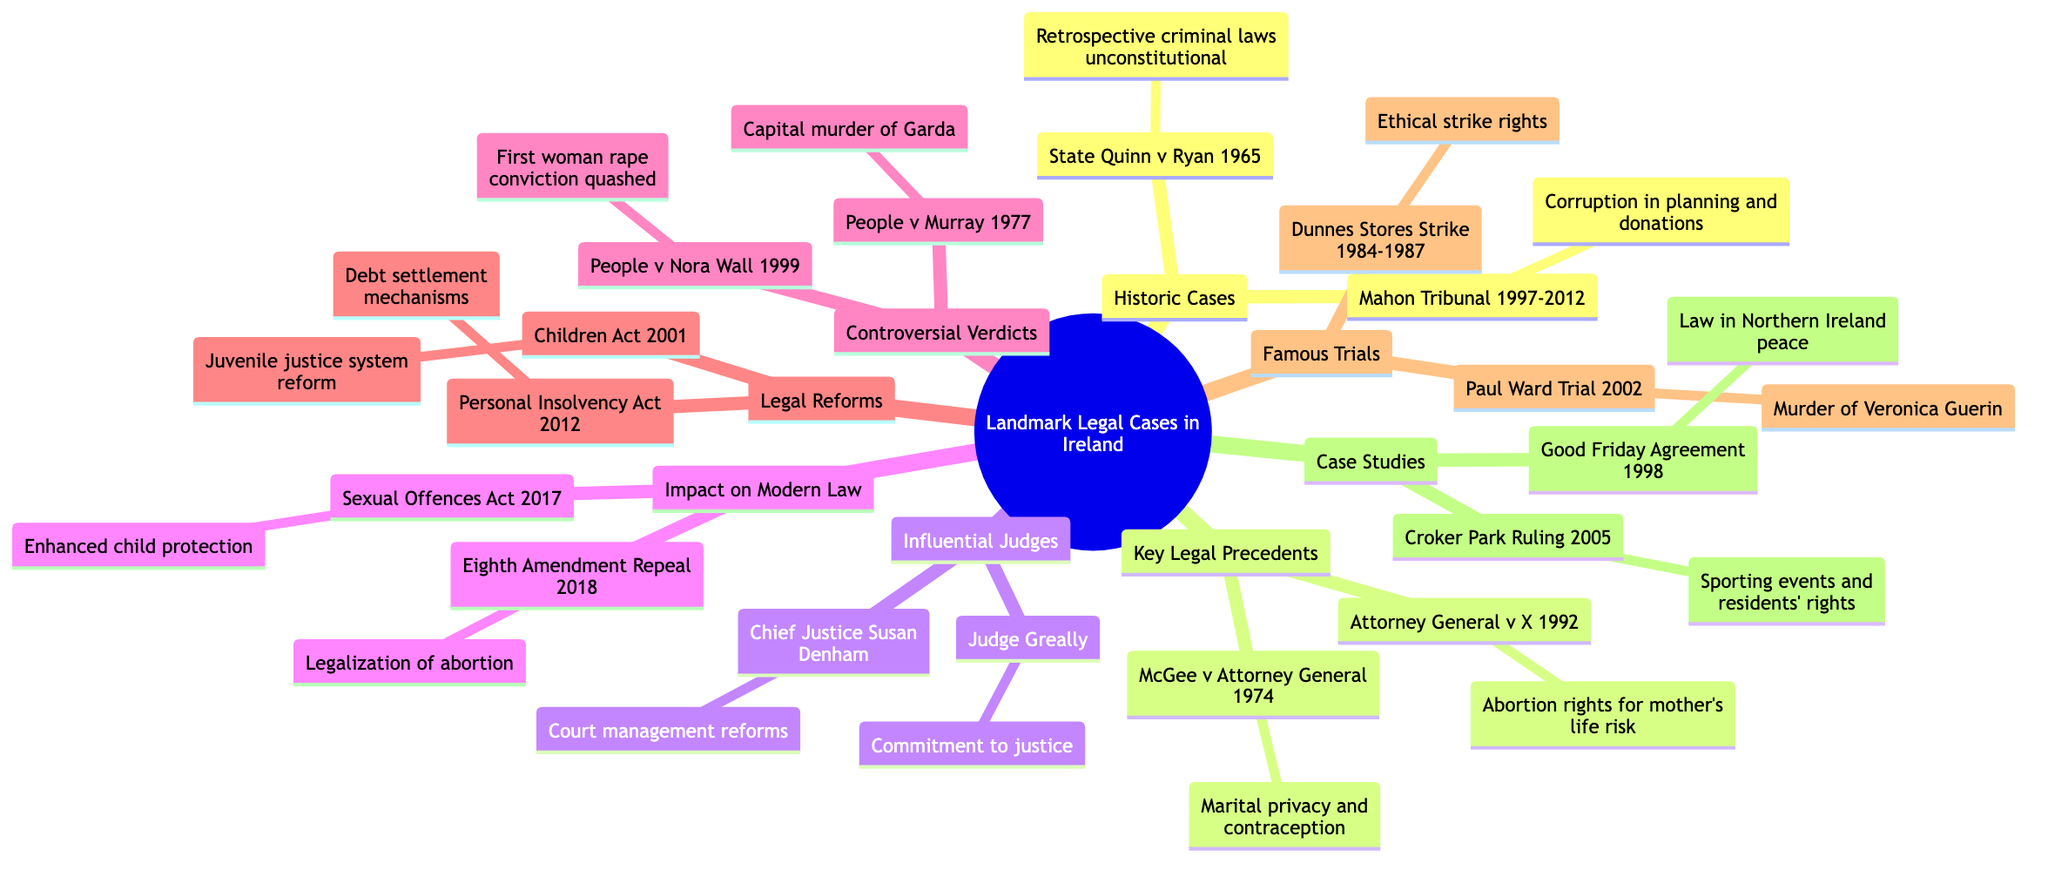What case established that retrospective criminal laws are unconstitutional? The diagram indicates that "State (Quinn) v. Ryan (1965)" falls under the "Historic Cases" section and specifically states it established the principle regarding retrospective criminal laws.
Answer: State (Quinn) v. Ryan (1965) How many legal reforms are listed in the diagram? By examining the "Legal Reforms" branch, I count two cases: "Children Act (2001)" and "Personal Insolvency Act (2012)," which makes the total two.
Answer: 2 Which influential judge is known for court management reforms? The diagram lists "Chief Justice Susan Denham" under "Influential Judges," stating her significance is linked to reforms in court management.
Answer: Chief Justice Susan Denham What famous trial involved the murder of journalist Veronica Guerin? The diagram mentions the "Paul Ward Trial (2002)" under the "Famous Trials" section, specifying it relates to the murder of Veronica Guerin.
Answer: Paul Ward Trial (2002) Which act was repealed leading to the legalization of abortion? The diagram shows "Eighth Amendment Repeal (2018)" under "Impact on Modern Law," directly stating that it led to the legalization of abortion services.
Answer: Eighth Amendment Repeal (2018) What was the outcome of People (DPP) v. Nora Wall? According to the "Controversial Verdicts" section, the diagram states this case resulted in the first woman convicted of rape, with the conviction later quashed due to mishandling.
Answer: Conviction later quashed Which historic case investigated corruption in planning permissions? The diagram identifies "Mahon Tribunal (1997-2012)" under the "Historic Cases," noting it investigated corruption related to planning permissions and political donations.
Answer: Mahon Tribunal (1997-2012) What key legal precedent affirmed marital privacy and contraceptive use? The diagram indicates that "McGee v. Attorney General (1974)" is the key case under "Key Legal Precedents" that affirmed marital privacy concerning contraceptives.
Answer: McGee v. Attorney General (1974) How many case studies are mentioned in the diagram? I see two case studies listed in the "Case Studies" section: "Good Friday Agreement (1998)" and "Croker Park Ruling (2005)," totaling two.
Answer: 2 